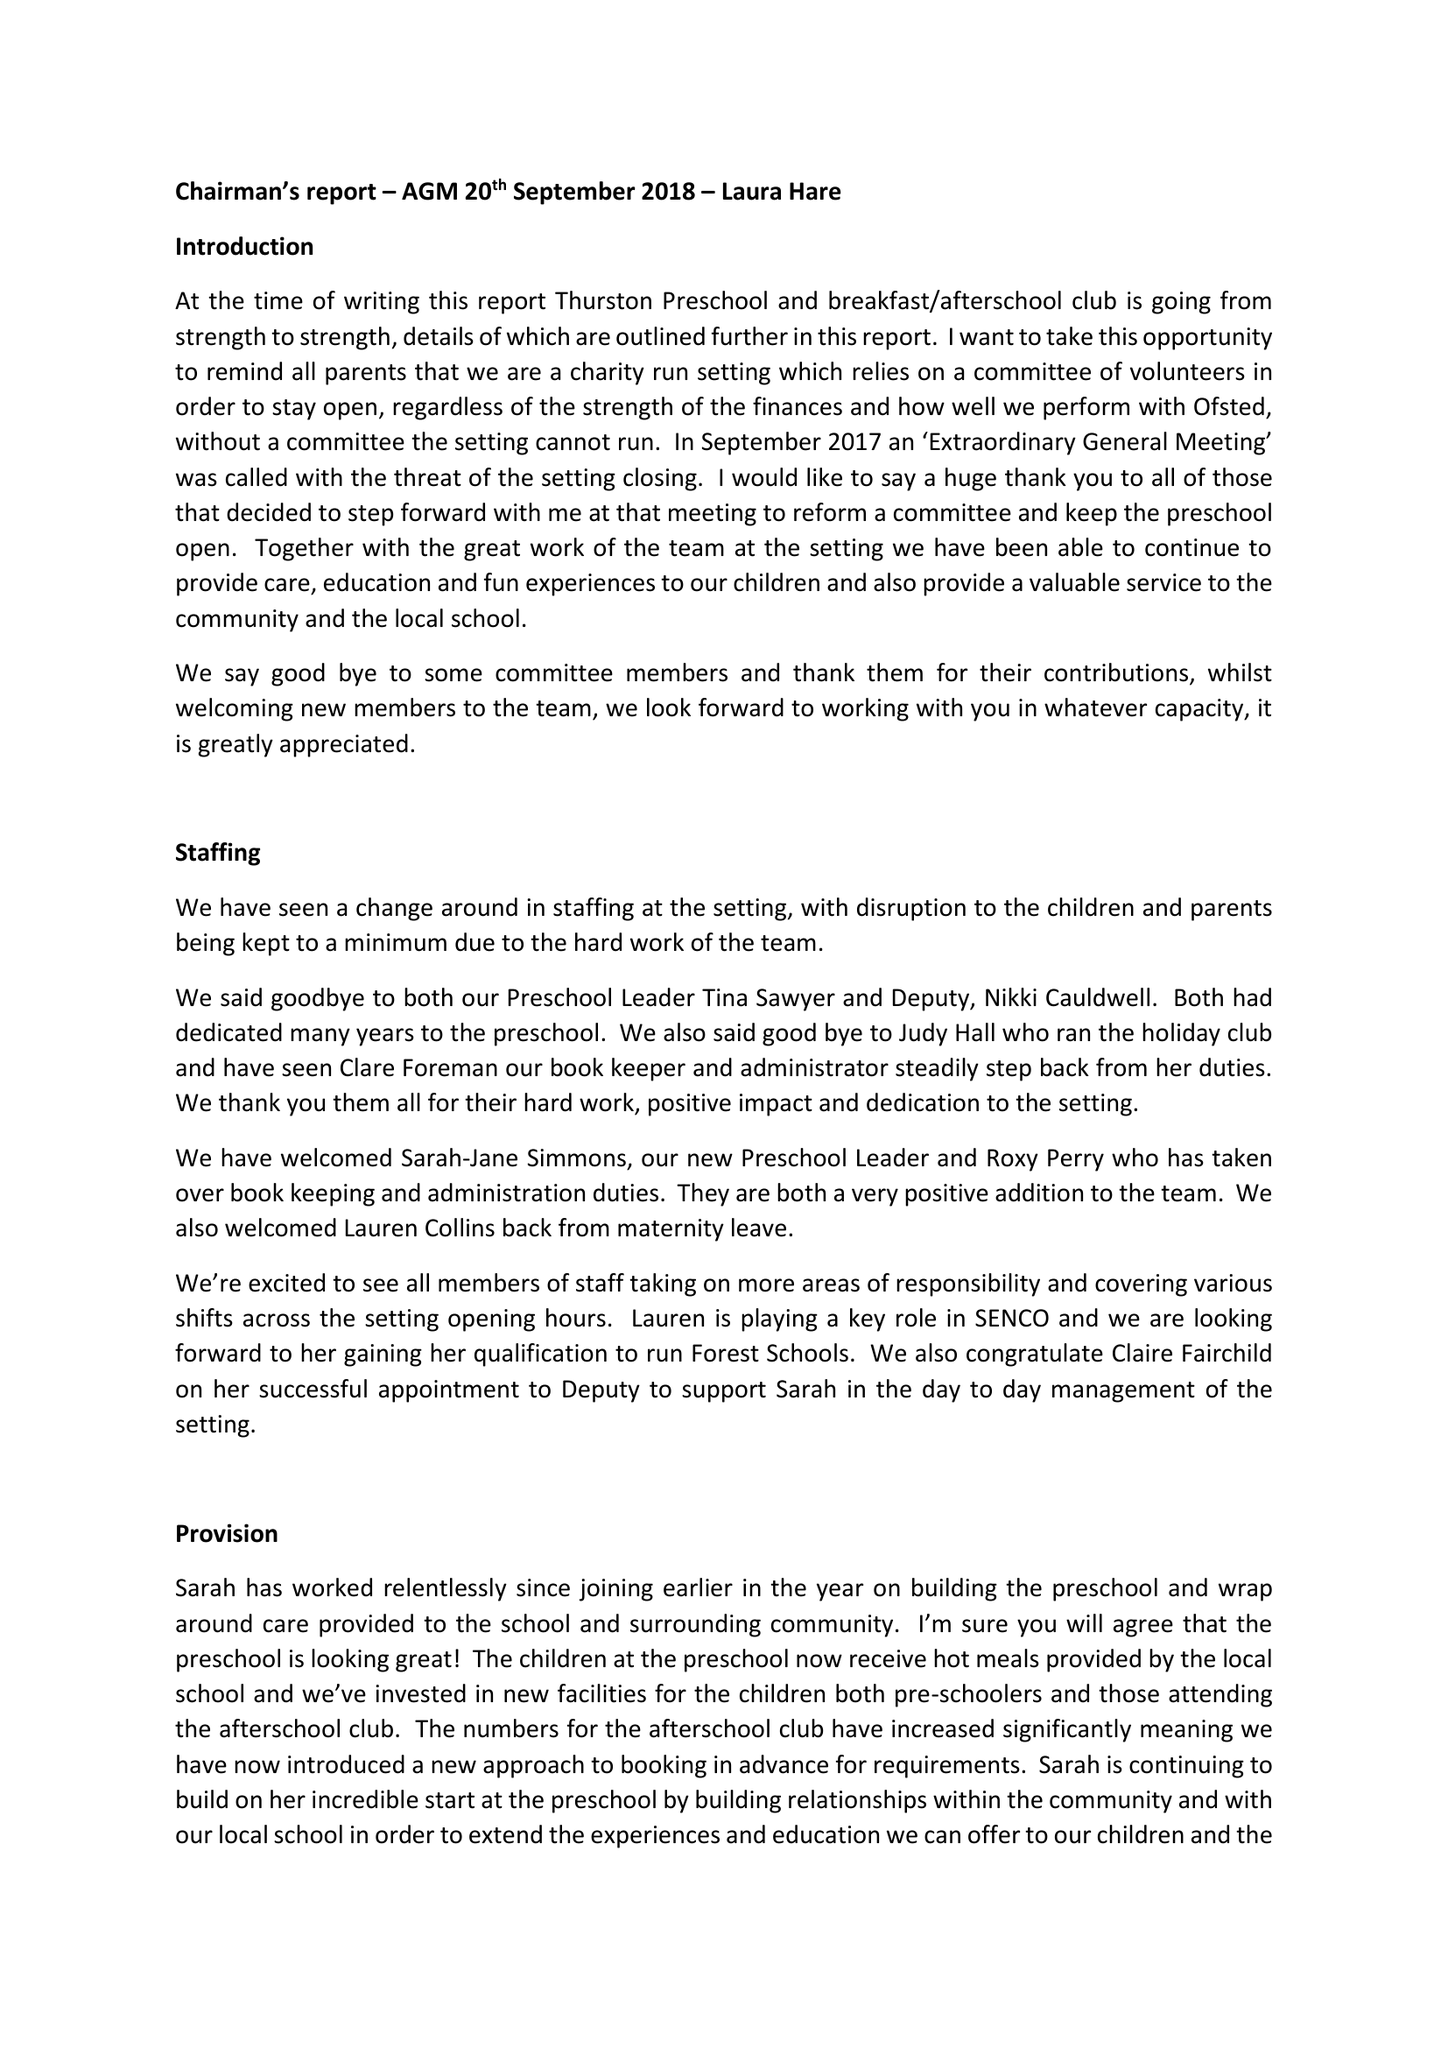What is the value for the address__post_town?
Answer the question using a single word or phrase. BURY ST. EDMUNDS 